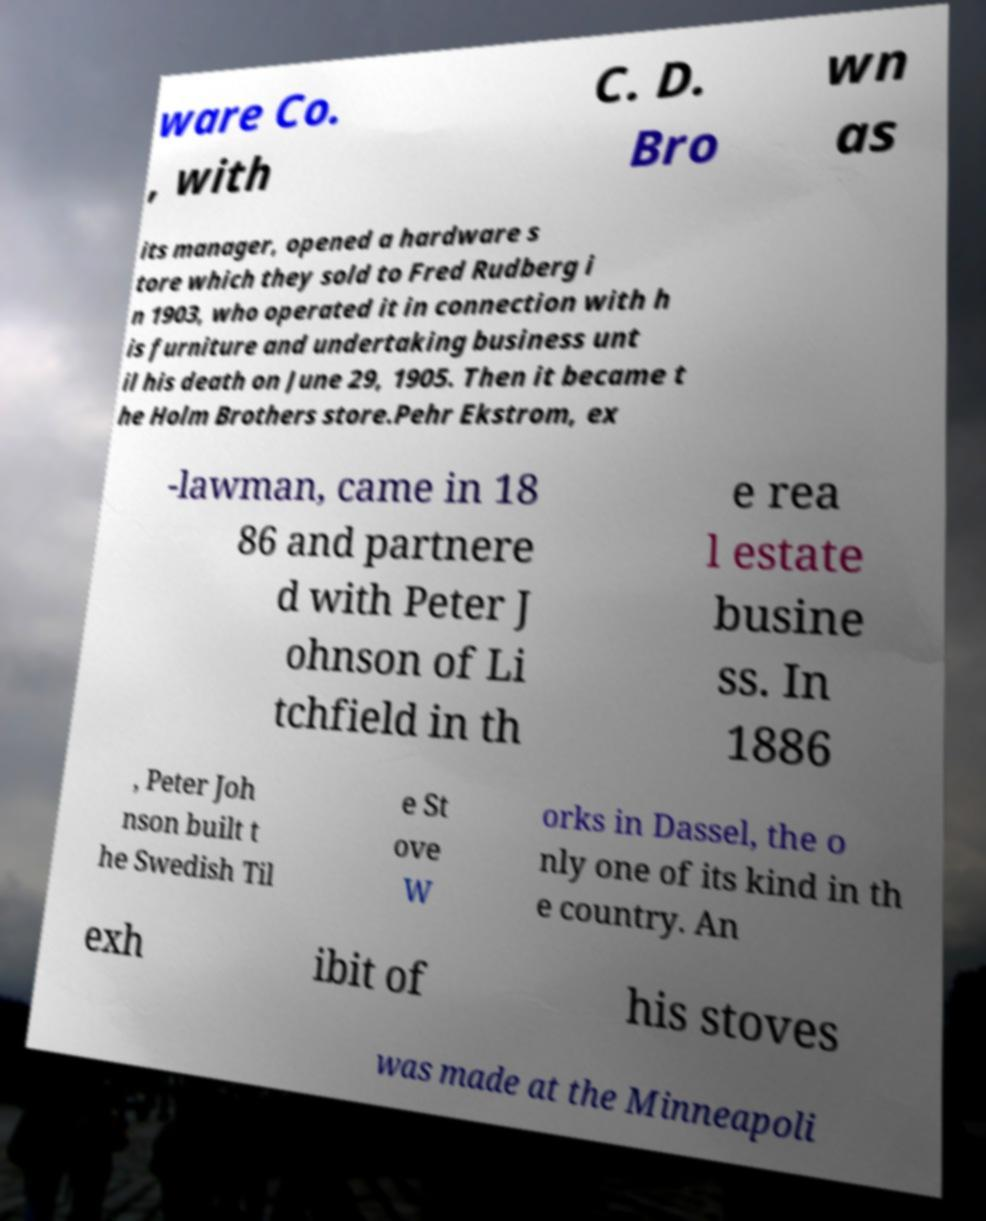Could you assist in decoding the text presented in this image and type it out clearly? ware Co. , with C. D. Bro wn as its manager, opened a hardware s tore which they sold to Fred Rudberg i n 1903, who operated it in connection with h is furniture and undertaking business unt il his death on June 29, 1905. Then it became t he Holm Brothers store.Pehr Ekstrom, ex -lawman, came in 18 86 and partnere d with Peter J ohnson of Li tchfield in th e rea l estate busine ss. In 1886 , Peter Joh nson built t he Swedish Til e St ove W orks in Dassel, the o nly one of its kind in th e country. An exh ibit of his stoves was made at the Minneapoli 